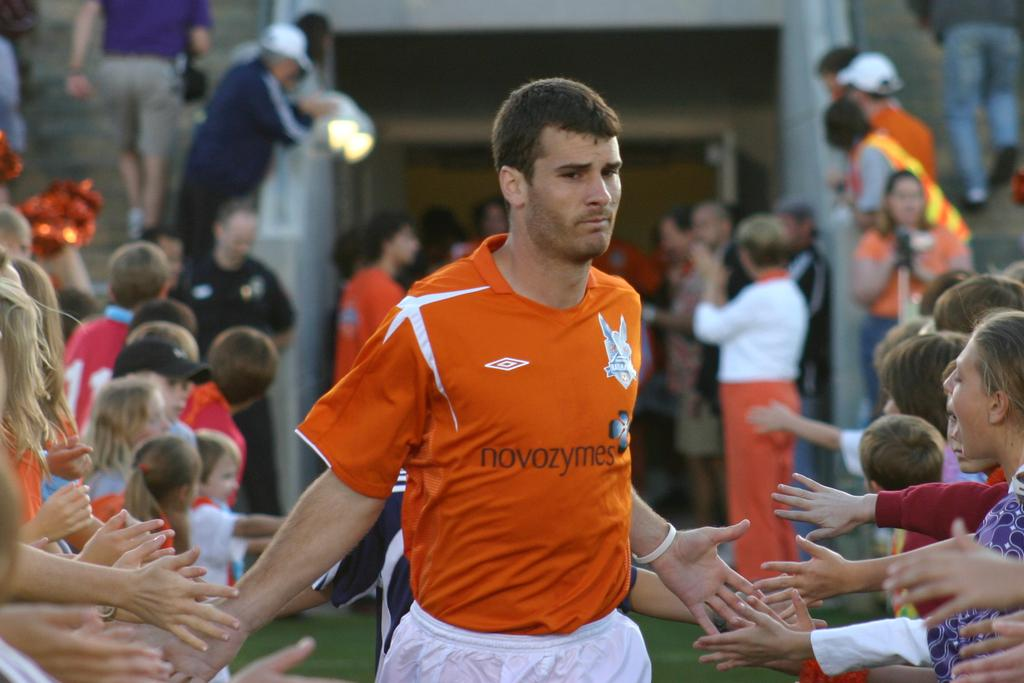<image>
Offer a succinct explanation of the picture presented. The footballer in the orange top is sponsored by Novozymes. 